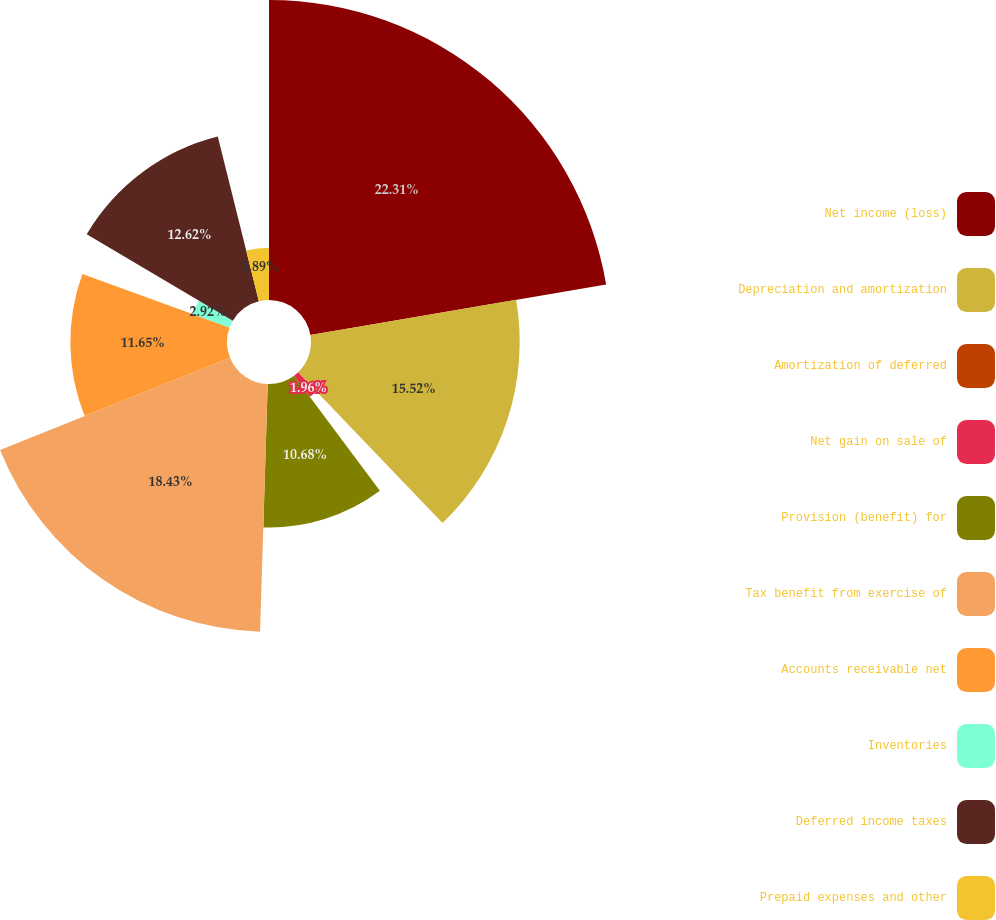Convert chart to OTSL. <chart><loc_0><loc_0><loc_500><loc_500><pie_chart><fcel>Net income (loss)<fcel>Depreciation and amortization<fcel>Amortization of deferred<fcel>Net gain on sale of<fcel>Provision (benefit) for<fcel>Tax benefit from exercise of<fcel>Accounts receivable net<fcel>Inventories<fcel>Deferred income taxes<fcel>Prepaid expenses and other<nl><fcel>22.31%<fcel>15.52%<fcel>0.02%<fcel>1.96%<fcel>10.68%<fcel>18.43%<fcel>11.65%<fcel>2.92%<fcel>12.62%<fcel>3.89%<nl></chart> 